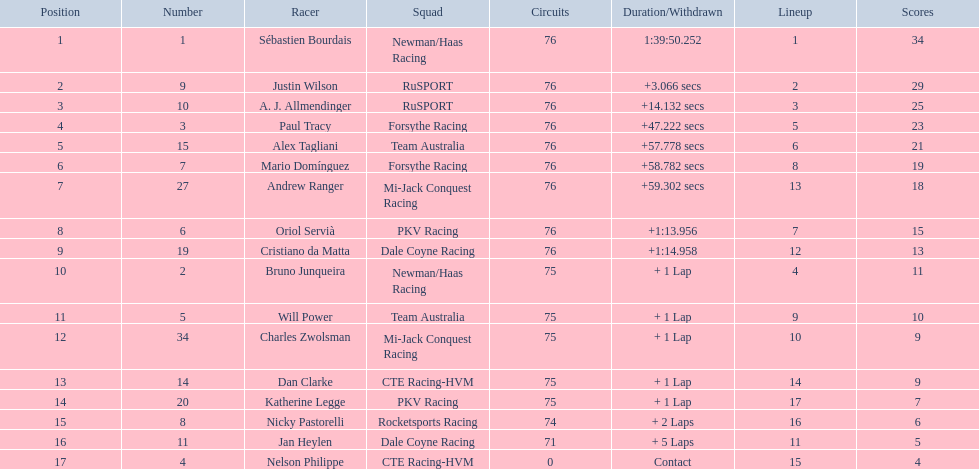What was alex taglini's final score in the tecate grand prix? 21. What was paul tracy's final score in the tecate grand prix? 23. Could you parse the entire table as a dict? {'header': ['Position', 'Number', 'Racer', 'Squad', 'Circuits', 'Duration/Withdrawn', 'Lineup', 'Scores'], 'rows': [['1', '1', 'Sébastien Bourdais', 'Newman/Haas Racing', '76', '1:39:50.252', '1', '34'], ['2', '9', 'Justin Wilson', 'RuSPORT', '76', '+3.066 secs', '2', '29'], ['3', '10', 'A. J. Allmendinger', 'RuSPORT', '76', '+14.132 secs', '3', '25'], ['4', '3', 'Paul Tracy', 'Forsythe Racing', '76', '+47.222 secs', '5', '23'], ['5', '15', 'Alex Tagliani', 'Team Australia', '76', '+57.778 secs', '6', '21'], ['6', '7', 'Mario Domínguez', 'Forsythe Racing', '76', '+58.782 secs', '8', '19'], ['7', '27', 'Andrew Ranger', 'Mi-Jack Conquest Racing', '76', '+59.302 secs', '13', '18'], ['8', '6', 'Oriol Servià', 'PKV Racing', '76', '+1:13.956', '7', '15'], ['9', '19', 'Cristiano da Matta', 'Dale Coyne Racing', '76', '+1:14.958', '12', '13'], ['10', '2', 'Bruno Junqueira', 'Newman/Haas Racing', '75', '+ 1 Lap', '4', '11'], ['11', '5', 'Will Power', 'Team Australia', '75', '+ 1 Lap', '9', '10'], ['12', '34', 'Charles Zwolsman', 'Mi-Jack Conquest Racing', '75', '+ 1 Lap', '10', '9'], ['13', '14', 'Dan Clarke', 'CTE Racing-HVM', '75', '+ 1 Lap', '14', '9'], ['14', '20', 'Katherine Legge', 'PKV Racing', '75', '+ 1 Lap', '17', '7'], ['15', '8', 'Nicky Pastorelli', 'Rocketsports Racing', '74', '+ 2 Laps', '16', '6'], ['16', '11', 'Jan Heylen', 'Dale Coyne Racing', '71', '+ 5 Laps', '11', '5'], ['17', '4', 'Nelson Philippe', 'CTE Racing-HVM', '0', 'Contact', '15', '4']]} Which driver finished first? Paul Tracy. 